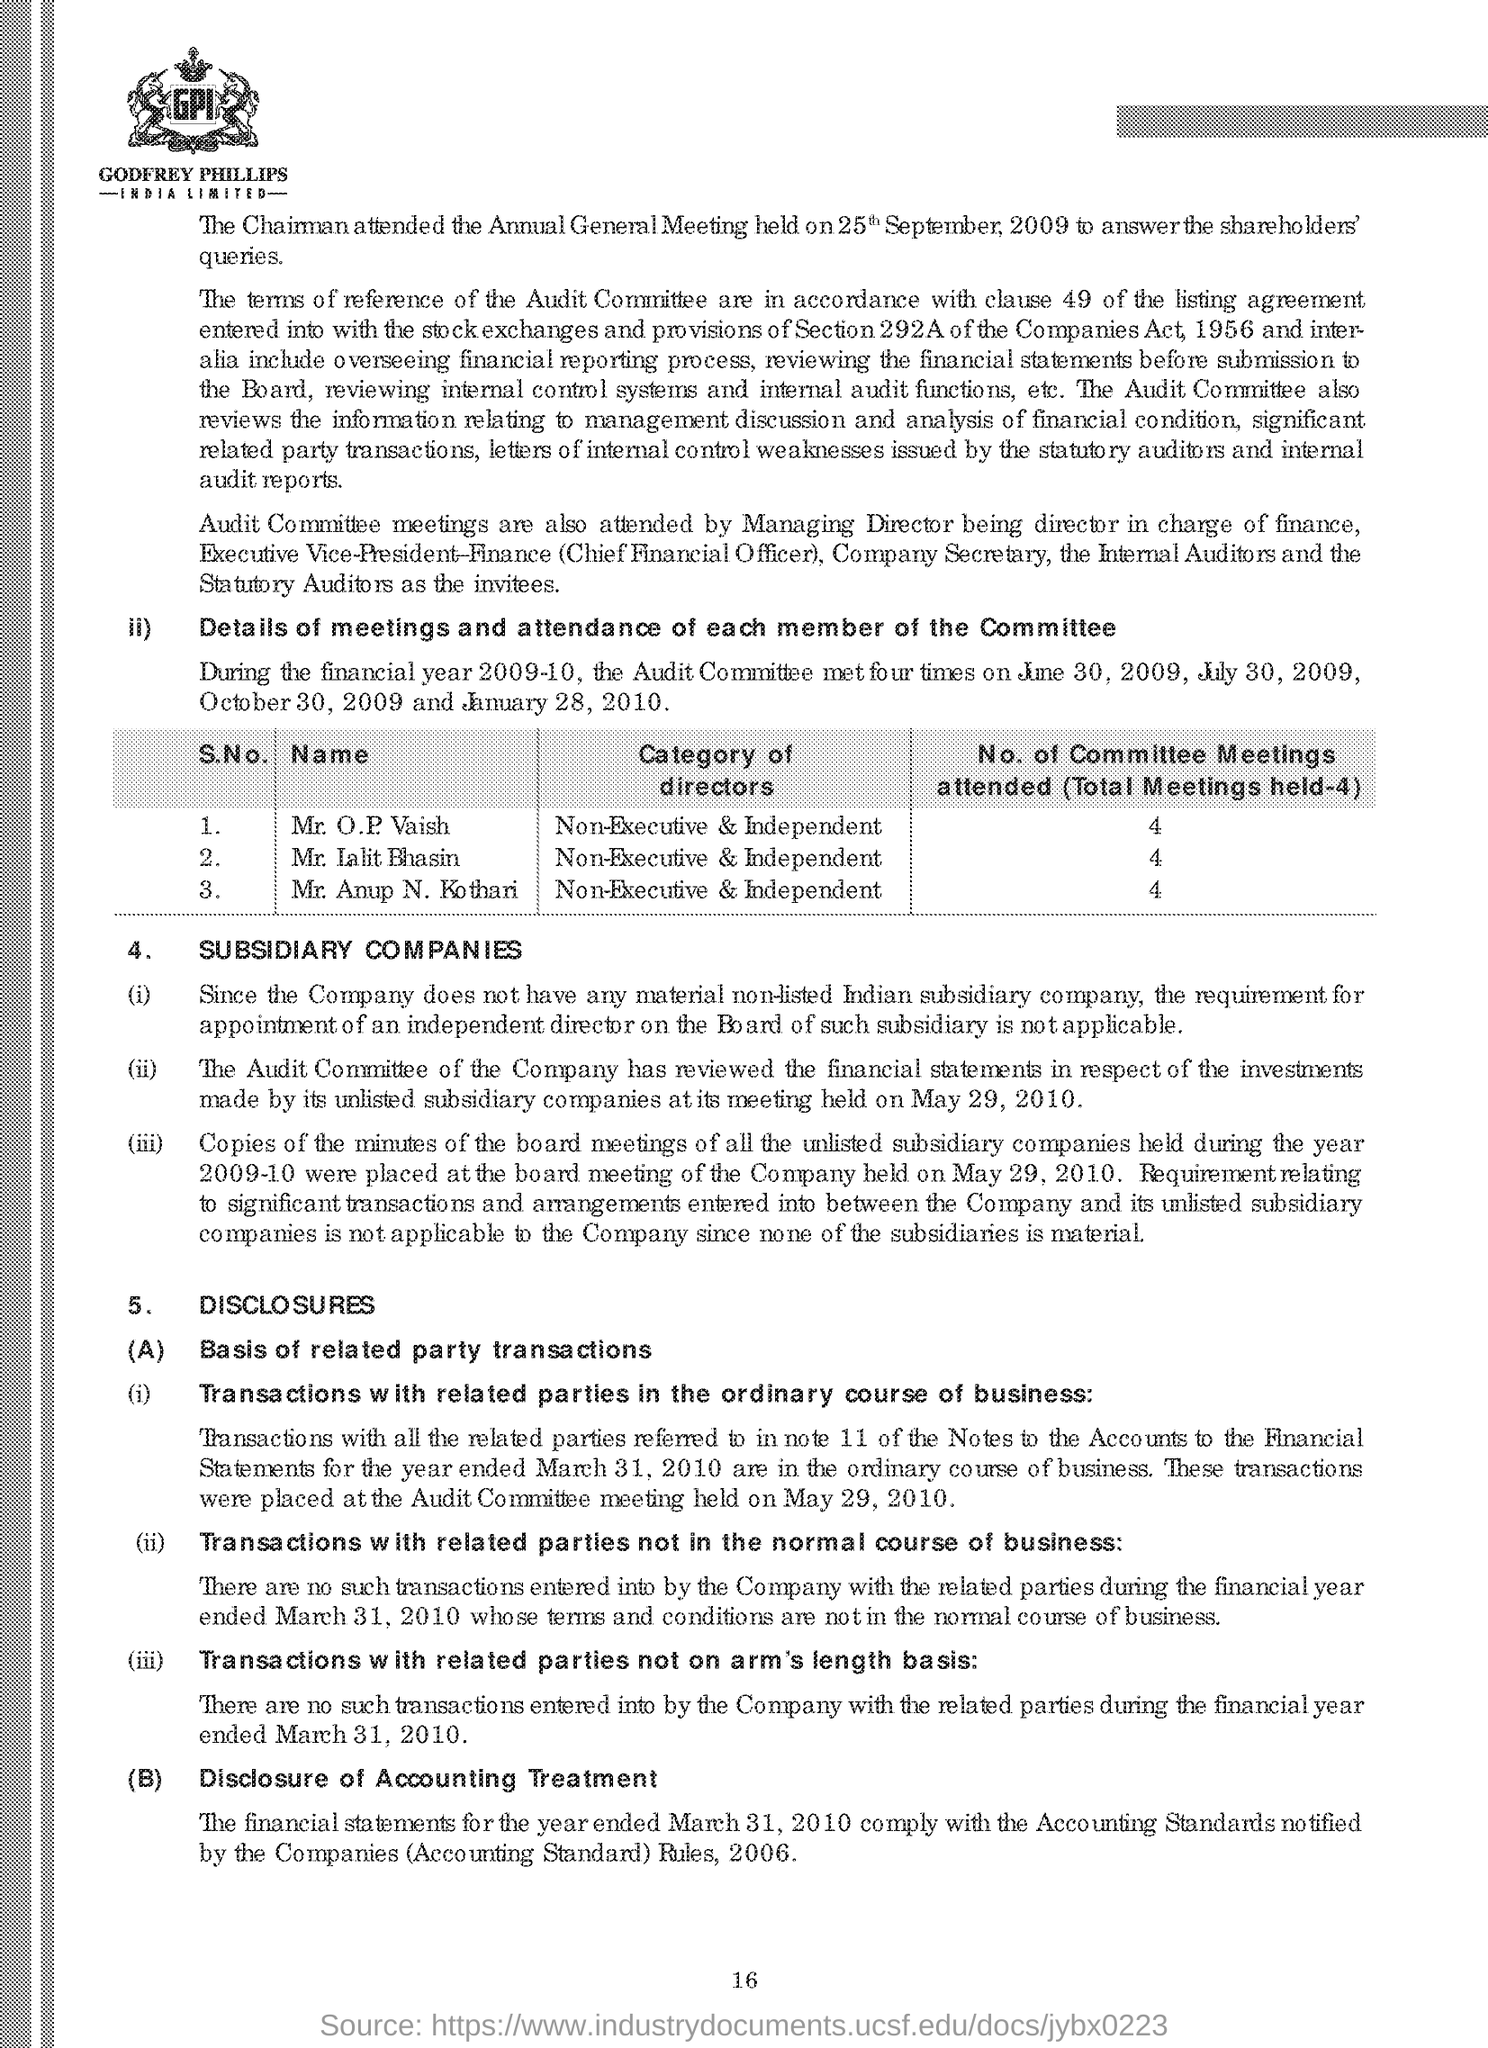How many directors are mentioned to attend committee meetings?
Your response must be concise. 3. What is the category of directors who attend the committee meetings?
Give a very brief answer. Non-Executive & Independent. 